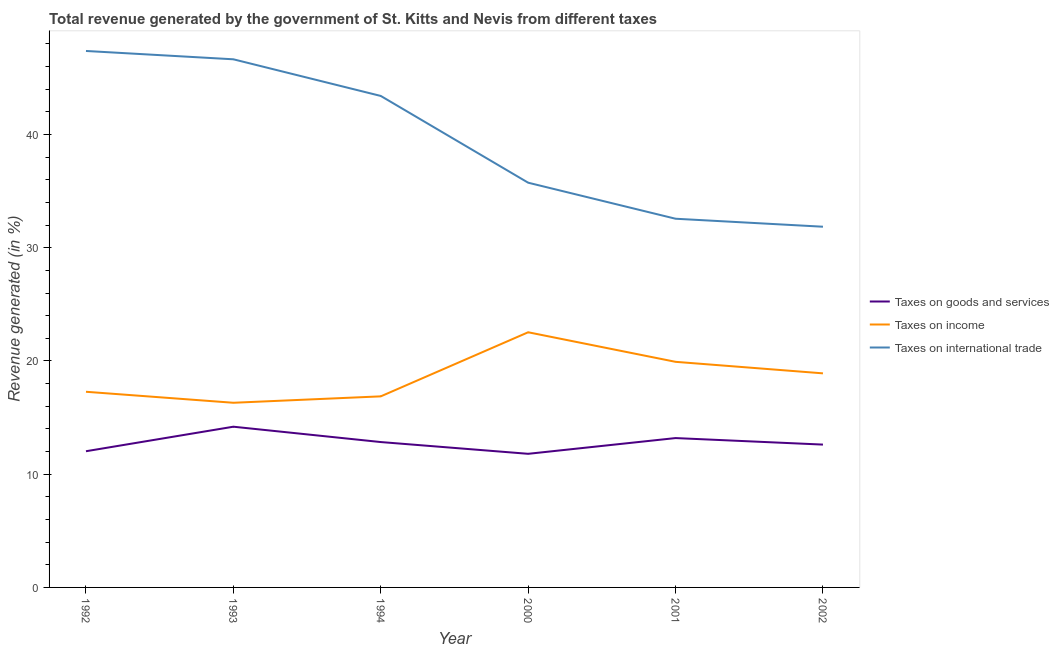Does the line corresponding to percentage of revenue generated by taxes on goods and services intersect with the line corresponding to percentage of revenue generated by tax on international trade?
Keep it short and to the point. No. Is the number of lines equal to the number of legend labels?
Provide a succinct answer. Yes. What is the percentage of revenue generated by tax on international trade in 2000?
Your response must be concise. 35.74. Across all years, what is the maximum percentage of revenue generated by taxes on goods and services?
Your answer should be very brief. 14.19. Across all years, what is the minimum percentage of revenue generated by taxes on goods and services?
Provide a short and direct response. 11.8. In which year was the percentage of revenue generated by taxes on goods and services minimum?
Keep it short and to the point. 2000. What is the total percentage of revenue generated by tax on international trade in the graph?
Provide a short and direct response. 237.59. What is the difference between the percentage of revenue generated by taxes on goods and services in 2001 and that in 2002?
Your answer should be very brief. 0.58. What is the difference between the percentage of revenue generated by taxes on income in 1993 and the percentage of revenue generated by tax on international trade in 2000?
Your response must be concise. -19.44. What is the average percentage of revenue generated by taxes on income per year?
Make the answer very short. 18.64. In the year 1994, what is the difference between the percentage of revenue generated by taxes on income and percentage of revenue generated by tax on international trade?
Offer a very short reply. -26.53. In how many years, is the percentage of revenue generated by tax on international trade greater than 24 %?
Give a very brief answer. 6. What is the ratio of the percentage of revenue generated by tax on international trade in 2000 to that in 2002?
Give a very brief answer. 1.12. Is the percentage of revenue generated by taxes on goods and services in 1992 less than that in 2000?
Provide a short and direct response. No. What is the difference between the highest and the second highest percentage of revenue generated by taxes on income?
Provide a short and direct response. 2.61. What is the difference between the highest and the lowest percentage of revenue generated by taxes on goods and services?
Provide a succinct answer. 2.39. In how many years, is the percentage of revenue generated by taxes on income greater than the average percentage of revenue generated by taxes on income taken over all years?
Your answer should be compact. 3. Is the sum of the percentage of revenue generated by taxes on goods and services in 2000 and 2001 greater than the maximum percentage of revenue generated by tax on international trade across all years?
Your answer should be compact. No. Is it the case that in every year, the sum of the percentage of revenue generated by taxes on goods and services and percentage of revenue generated by taxes on income is greater than the percentage of revenue generated by tax on international trade?
Ensure brevity in your answer.  No. Does the percentage of revenue generated by tax on international trade monotonically increase over the years?
Give a very brief answer. No. How many years are there in the graph?
Keep it short and to the point. 6. What is the difference between two consecutive major ticks on the Y-axis?
Offer a very short reply. 10. Are the values on the major ticks of Y-axis written in scientific E-notation?
Provide a succinct answer. No. Where does the legend appear in the graph?
Keep it short and to the point. Center right. How many legend labels are there?
Your response must be concise. 3. How are the legend labels stacked?
Your answer should be compact. Vertical. What is the title of the graph?
Offer a very short reply. Total revenue generated by the government of St. Kitts and Nevis from different taxes. Does "Taxes" appear as one of the legend labels in the graph?
Ensure brevity in your answer.  No. What is the label or title of the X-axis?
Offer a terse response. Year. What is the label or title of the Y-axis?
Your answer should be compact. Revenue generated (in %). What is the Revenue generated (in %) of Taxes on goods and services in 1992?
Ensure brevity in your answer.  12.03. What is the Revenue generated (in %) in Taxes on income in 1992?
Your response must be concise. 17.28. What is the Revenue generated (in %) of Taxes on international trade in 1992?
Your response must be concise. 47.38. What is the Revenue generated (in %) of Taxes on goods and services in 1993?
Offer a very short reply. 14.19. What is the Revenue generated (in %) in Taxes on income in 1993?
Keep it short and to the point. 16.31. What is the Revenue generated (in %) in Taxes on international trade in 1993?
Your answer should be very brief. 46.64. What is the Revenue generated (in %) in Taxes on goods and services in 1994?
Your answer should be very brief. 12.84. What is the Revenue generated (in %) of Taxes on income in 1994?
Ensure brevity in your answer.  16.87. What is the Revenue generated (in %) in Taxes on international trade in 1994?
Offer a terse response. 43.41. What is the Revenue generated (in %) of Taxes on goods and services in 2000?
Keep it short and to the point. 11.8. What is the Revenue generated (in %) in Taxes on income in 2000?
Provide a short and direct response. 22.54. What is the Revenue generated (in %) in Taxes on international trade in 2000?
Offer a terse response. 35.74. What is the Revenue generated (in %) in Taxes on goods and services in 2001?
Make the answer very short. 13.19. What is the Revenue generated (in %) of Taxes on income in 2001?
Offer a terse response. 19.92. What is the Revenue generated (in %) of Taxes on international trade in 2001?
Your answer should be very brief. 32.56. What is the Revenue generated (in %) in Taxes on goods and services in 2002?
Ensure brevity in your answer.  12.61. What is the Revenue generated (in %) of Taxes on income in 2002?
Your answer should be very brief. 18.91. What is the Revenue generated (in %) in Taxes on international trade in 2002?
Offer a very short reply. 31.86. Across all years, what is the maximum Revenue generated (in %) in Taxes on goods and services?
Provide a short and direct response. 14.19. Across all years, what is the maximum Revenue generated (in %) of Taxes on income?
Your answer should be very brief. 22.54. Across all years, what is the maximum Revenue generated (in %) of Taxes on international trade?
Your answer should be compact. 47.38. Across all years, what is the minimum Revenue generated (in %) in Taxes on goods and services?
Keep it short and to the point. 11.8. Across all years, what is the minimum Revenue generated (in %) of Taxes on income?
Make the answer very short. 16.31. Across all years, what is the minimum Revenue generated (in %) of Taxes on international trade?
Your answer should be compact. 31.86. What is the total Revenue generated (in %) of Taxes on goods and services in the graph?
Your answer should be very brief. 76.67. What is the total Revenue generated (in %) in Taxes on income in the graph?
Your answer should be very brief. 111.83. What is the total Revenue generated (in %) of Taxes on international trade in the graph?
Ensure brevity in your answer.  237.59. What is the difference between the Revenue generated (in %) of Taxes on goods and services in 1992 and that in 1993?
Provide a succinct answer. -2.17. What is the difference between the Revenue generated (in %) in Taxes on income in 1992 and that in 1993?
Give a very brief answer. 0.97. What is the difference between the Revenue generated (in %) of Taxes on international trade in 1992 and that in 1993?
Offer a terse response. 0.74. What is the difference between the Revenue generated (in %) of Taxes on goods and services in 1992 and that in 1994?
Offer a very short reply. -0.81. What is the difference between the Revenue generated (in %) in Taxes on income in 1992 and that in 1994?
Your answer should be very brief. 0.4. What is the difference between the Revenue generated (in %) in Taxes on international trade in 1992 and that in 1994?
Offer a very short reply. 3.97. What is the difference between the Revenue generated (in %) in Taxes on goods and services in 1992 and that in 2000?
Your answer should be compact. 0.23. What is the difference between the Revenue generated (in %) of Taxes on income in 1992 and that in 2000?
Offer a terse response. -5.26. What is the difference between the Revenue generated (in %) of Taxes on international trade in 1992 and that in 2000?
Your response must be concise. 11.63. What is the difference between the Revenue generated (in %) in Taxes on goods and services in 1992 and that in 2001?
Keep it short and to the point. -1.16. What is the difference between the Revenue generated (in %) of Taxes on income in 1992 and that in 2001?
Your answer should be very brief. -2.64. What is the difference between the Revenue generated (in %) in Taxes on international trade in 1992 and that in 2001?
Offer a terse response. 14.82. What is the difference between the Revenue generated (in %) in Taxes on goods and services in 1992 and that in 2002?
Give a very brief answer. -0.59. What is the difference between the Revenue generated (in %) in Taxes on income in 1992 and that in 2002?
Offer a very short reply. -1.63. What is the difference between the Revenue generated (in %) in Taxes on international trade in 1992 and that in 2002?
Your answer should be compact. 15.52. What is the difference between the Revenue generated (in %) in Taxes on goods and services in 1993 and that in 1994?
Give a very brief answer. 1.35. What is the difference between the Revenue generated (in %) in Taxes on income in 1993 and that in 1994?
Your answer should be very brief. -0.57. What is the difference between the Revenue generated (in %) in Taxes on international trade in 1993 and that in 1994?
Offer a terse response. 3.24. What is the difference between the Revenue generated (in %) in Taxes on goods and services in 1993 and that in 2000?
Keep it short and to the point. 2.39. What is the difference between the Revenue generated (in %) in Taxes on income in 1993 and that in 2000?
Make the answer very short. -6.23. What is the difference between the Revenue generated (in %) of Taxes on international trade in 1993 and that in 2000?
Your answer should be very brief. 10.9. What is the difference between the Revenue generated (in %) of Taxes on goods and services in 1993 and that in 2001?
Ensure brevity in your answer.  1. What is the difference between the Revenue generated (in %) of Taxes on income in 1993 and that in 2001?
Give a very brief answer. -3.62. What is the difference between the Revenue generated (in %) of Taxes on international trade in 1993 and that in 2001?
Offer a terse response. 14.08. What is the difference between the Revenue generated (in %) of Taxes on goods and services in 1993 and that in 2002?
Provide a short and direct response. 1.58. What is the difference between the Revenue generated (in %) of Taxes on income in 1993 and that in 2002?
Provide a succinct answer. -2.6. What is the difference between the Revenue generated (in %) of Taxes on international trade in 1993 and that in 2002?
Provide a short and direct response. 14.79. What is the difference between the Revenue generated (in %) in Taxes on goods and services in 1994 and that in 2000?
Your answer should be very brief. 1.04. What is the difference between the Revenue generated (in %) in Taxes on income in 1994 and that in 2000?
Your answer should be very brief. -5.66. What is the difference between the Revenue generated (in %) in Taxes on international trade in 1994 and that in 2000?
Make the answer very short. 7.66. What is the difference between the Revenue generated (in %) of Taxes on goods and services in 1994 and that in 2001?
Give a very brief answer. -0.35. What is the difference between the Revenue generated (in %) in Taxes on income in 1994 and that in 2001?
Your response must be concise. -3.05. What is the difference between the Revenue generated (in %) of Taxes on international trade in 1994 and that in 2001?
Your answer should be very brief. 10.84. What is the difference between the Revenue generated (in %) of Taxes on goods and services in 1994 and that in 2002?
Make the answer very short. 0.22. What is the difference between the Revenue generated (in %) in Taxes on income in 1994 and that in 2002?
Your response must be concise. -2.03. What is the difference between the Revenue generated (in %) in Taxes on international trade in 1994 and that in 2002?
Keep it short and to the point. 11.55. What is the difference between the Revenue generated (in %) of Taxes on goods and services in 2000 and that in 2001?
Offer a terse response. -1.39. What is the difference between the Revenue generated (in %) in Taxes on income in 2000 and that in 2001?
Offer a very short reply. 2.61. What is the difference between the Revenue generated (in %) in Taxes on international trade in 2000 and that in 2001?
Offer a very short reply. 3.18. What is the difference between the Revenue generated (in %) of Taxes on goods and services in 2000 and that in 2002?
Provide a succinct answer. -0.81. What is the difference between the Revenue generated (in %) of Taxes on income in 2000 and that in 2002?
Give a very brief answer. 3.63. What is the difference between the Revenue generated (in %) in Taxes on international trade in 2000 and that in 2002?
Provide a short and direct response. 3.89. What is the difference between the Revenue generated (in %) of Taxes on goods and services in 2001 and that in 2002?
Ensure brevity in your answer.  0.58. What is the difference between the Revenue generated (in %) of Taxes on income in 2001 and that in 2002?
Make the answer very short. 1.02. What is the difference between the Revenue generated (in %) of Taxes on international trade in 2001 and that in 2002?
Keep it short and to the point. 0.71. What is the difference between the Revenue generated (in %) in Taxes on goods and services in 1992 and the Revenue generated (in %) in Taxes on income in 1993?
Keep it short and to the point. -4.28. What is the difference between the Revenue generated (in %) of Taxes on goods and services in 1992 and the Revenue generated (in %) of Taxes on international trade in 1993?
Provide a succinct answer. -34.62. What is the difference between the Revenue generated (in %) of Taxes on income in 1992 and the Revenue generated (in %) of Taxes on international trade in 1993?
Ensure brevity in your answer.  -29.36. What is the difference between the Revenue generated (in %) of Taxes on goods and services in 1992 and the Revenue generated (in %) of Taxes on income in 1994?
Your answer should be compact. -4.85. What is the difference between the Revenue generated (in %) in Taxes on goods and services in 1992 and the Revenue generated (in %) in Taxes on international trade in 1994?
Offer a very short reply. -31.38. What is the difference between the Revenue generated (in %) of Taxes on income in 1992 and the Revenue generated (in %) of Taxes on international trade in 1994?
Your answer should be very brief. -26.13. What is the difference between the Revenue generated (in %) in Taxes on goods and services in 1992 and the Revenue generated (in %) in Taxes on income in 2000?
Your answer should be very brief. -10.51. What is the difference between the Revenue generated (in %) of Taxes on goods and services in 1992 and the Revenue generated (in %) of Taxes on international trade in 2000?
Keep it short and to the point. -23.72. What is the difference between the Revenue generated (in %) in Taxes on income in 1992 and the Revenue generated (in %) in Taxes on international trade in 2000?
Provide a short and direct response. -18.46. What is the difference between the Revenue generated (in %) of Taxes on goods and services in 1992 and the Revenue generated (in %) of Taxes on income in 2001?
Make the answer very short. -7.9. What is the difference between the Revenue generated (in %) in Taxes on goods and services in 1992 and the Revenue generated (in %) in Taxes on international trade in 2001?
Your response must be concise. -20.53. What is the difference between the Revenue generated (in %) in Taxes on income in 1992 and the Revenue generated (in %) in Taxes on international trade in 2001?
Provide a short and direct response. -15.28. What is the difference between the Revenue generated (in %) in Taxes on goods and services in 1992 and the Revenue generated (in %) in Taxes on income in 2002?
Make the answer very short. -6.88. What is the difference between the Revenue generated (in %) of Taxes on goods and services in 1992 and the Revenue generated (in %) of Taxes on international trade in 2002?
Offer a terse response. -19.83. What is the difference between the Revenue generated (in %) in Taxes on income in 1992 and the Revenue generated (in %) in Taxes on international trade in 2002?
Keep it short and to the point. -14.58. What is the difference between the Revenue generated (in %) of Taxes on goods and services in 1993 and the Revenue generated (in %) of Taxes on income in 1994?
Offer a terse response. -2.68. What is the difference between the Revenue generated (in %) in Taxes on goods and services in 1993 and the Revenue generated (in %) in Taxes on international trade in 1994?
Your answer should be very brief. -29.21. What is the difference between the Revenue generated (in %) in Taxes on income in 1993 and the Revenue generated (in %) in Taxes on international trade in 1994?
Ensure brevity in your answer.  -27.1. What is the difference between the Revenue generated (in %) of Taxes on goods and services in 1993 and the Revenue generated (in %) of Taxes on income in 2000?
Ensure brevity in your answer.  -8.34. What is the difference between the Revenue generated (in %) in Taxes on goods and services in 1993 and the Revenue generated (in %) in Taxes on international trade in 2000?
Ensure brevity in your answer.  -21.55. What is the difference between the Revenue generated (in %) of Taxes on income in 1993 and the Revenue generated (in %) of Taxes on international trade in 2000?
Provide a succinct answer. -19.44. What is the difference between the Revenue generated (in %) in Taxes on goods and services in 1993 and the Revenue generated (in %) in Taxes on income in 2001?
Your answer should be very brief. -5.73. What is the difference between the Revenue generated (in %) of Taxes on goods and services in 1993 and the Revenue generated (in %) of Taxes on international trade in 2001?
Give a very brief answer. -18.37. What is the difference between the Revenue generated (in %) of Taxes on income in 1993 and the Revenue generated (in %) of Taxes on international trade in 2001?
Provide a succinct answer. -16.25. What is the difference between the Revenue generated (in %) of Taxes on goods and services in 1993 and the Revenue generated (in %) of Taxes on income in 2002?
Your response must be concise. -4.71. What is the difference between the Revenue generated (in %) of Taxes on goods and services in 1993 and the Revenue generated (in %) of Taxes on international trade in 2002?
Offer a terse response. -17.66. What is the difference between the Revenue generated (in %) in Taxes on income in 1993 and the Revenue generated (in %) in Taxes on international trade in 2002?
Provide a short and direct response. -15.55. What is the difference between the Revenue generated (in %) of Taxes on goods and services in 1994 and the Revenue generated (in %) of Taxes on income in 2000?
Offer a terse response. -9.7. What is the difference between the Revenue generated (in %) in Taxes on goods and services in 1994 and the Revenue generated (in %) in Taxes on international trade in 2000?
Your response must be concise. -22.91. What is the difference between the Revenue generated (in %) of Taxes on income in 1994 and the Revenue generated (in %) of Taxes on international trade in 2000?
Your response must be concise. -18.87. What is the difference between the Revenue generated (in %) of Taxes on goods and services in 1994 and the Revenue generated (in %) of Taxes on income in 2001?
Make the answer very short. -7.09. What is the difference between the Revenue generated (in %) of Taxes on goods and services in 1994 and the Revenue generated (in %) of Taxes on international trade in 2001?
Your answer should be compact. -19.72. What is the difference between the Revenue generated (in %) in Taxes on income in 1994 and the Revenue generated (in %) in Taxes on international trade in 2001?
Offer a terse response. -15.69. What is the difference between the Revenue generated (in %) in Taxes on goods and services in 1994 and the Revenue generated (in %) in Taxes on income in 2002?
Offer a very short reply. -6.07. What is the difference between the Revenue generated (in %) of Taxes on goods and services in 1994 and the Revenue generated (in %) of Taxes on international trade in 2002?
Your answer should be very brief. -19.02. What is the difference between the Revenue generated (in %) of Taxes on income in 1994 and the Revenue generated (in %) of Taxes on international trade in 2002?
Offer a very short reply. -14.98. What is the difference between the Revenue generated (in %) in Taxes on goods and services in 2000 and the Revenue generated (in %) in Taxes on income in 2001?
Ensure brevity in your answer.  -8.12. What is the difference between the Revenue generated (in %) in Taxes on goods and services in 2000 and the Revenue generated (in %) in Taxes on international trade in 2001?
Your answer should be very brief. -20.76. What is the difference between the Revenue generated (in %) in Taxes on income in 2000 and the Revenue generated (in %) in Taxes on international trade in 2001?
Keep it short and to the point. -10.03. What is the difference between the Revenue generated (in %) of Taxes on goods and services in 2000 and the Revenue generated (in %) of Taxes on income in 2002?
Keep it short and to the point. -7.11. What is the difference between the Revenue generated (in %) in Taxes on goods and services in 2000 and the Revenue generated (in %) in Taxes on international trade in 2002?
Provide a short and direct response. -20.06. What is the difference between the Revenue generated (in %) of Taxes on income in 2000 and the Revenue generated (in %) of Taxes on international trade in 2002?
Provide a short and direct response. -9.32. What is the difference between the Revenue generated (in %) in Taxes on goods and services in 2001 and the Revenue generated (in %) in Taxes on income in 2002?
Your answer should be very brief. -5.72. What is the difference between the Revenue generated (in %) of Taxes on goods and services in 2001 and the Revenue generated (in %) of Taxes on international trade in 2002?
Your answer should be compact. -18.67. What is the difference between the Revenue generated (in %) in Taxes on income in 2001 and the Revenue generated (in %) in Taxes on international trade in 2002?
Give a very brief answer. -11.93. What is the average Revenue generated (in %) of Taxes on goods and services per year?
Provide a succinct answer. 12.78. What is the average Revenue generated (in %) of Taxes on income per year?
Your answer should be compact. 18.64. What is the average Revenue generated (in %) of Taxes on international trade per year?
Give a very brief answer. 39.6. In the year 1992, what is the difference between the Revenue generated (in %) in Taxes on goods and services and Revenue generated (in %) in Taxes on income?
Give a very brief answer. -5.25. In the year 1992, what is the difference between the Revenue generated (in %) in Taxes on goods and services and Revenue generated (in %) in Taxes on international trade?
Provide a succinct answer. -35.35. In the year 1992, what is the difference between the Revenue generated (in %) of Taxes on income and Revenue generated (in %) of Taxes on international trade?
Keep it short and to the point. -30.1. In the year 1993, what is the difference between the Revenue generated (in %) in Taxes on goods and services and Revenue generated (in %) in Taxes on income?
Your response must be concise. -2.12. In the year 1993, what is the difference between the Revenue generated (in %) in Taxes on goods and services and Revenue generated (in %) in Taxes on international trade?
Offer a very short reply. -32.45. In the year 1993, what is the difference between the Revenue generated (in %) of Taxes on income and Revenue generated (in %) of Taxes on international trade?
Offer a terse response. -30.33. In the year 1994, what is the difference between the Revenue generated (in %) in Taxes on goods and services and Revenue generated (in %) in Taxes on income?
Give a very brief answer. -4.04. In the year 1994, what is the difference between the Revenue generated (in %) of Taxes on goods and services and Revenue generated (in %) of Taxes on international trade?
Your answer should be very brief. -30.57. In the year 1994, what is the difference between the Revenue generated (in %) of Taxes on income and Revenue generated (in %) of Taxes on international trade?
Ensure brevity in your answer.  -26.53. In the year 2000, what is the difference between the Revenue generated (in %) of Taxes on goods and services and Revenue generated (in %) of Taxes on income?
Make the answer very short. -10.73. In the year 2000, what is the difference between the Revenue generated (in %) in Taxes on goods and services and Revenue generated (in %) in Taxes on international trade?
Offer a very short reply. -23.94. In the year 2000, what is the difference between the Revenue generated (in %) of Taxes on income and Revenue generated (in %) of Taxes on international trade?
Provide a short and direct response. -13.21. In the year 2001, what is the difference between the Revenue generated (in %) of Taxes on goods and services and Revenue generated (in %) of Taxes on income?
Offer a terse response. -6.73. In the year 2001, what is the difference between the Revenue generated (in %) in Taxes on goods and services and Revenue generated (in %) in Taxes on international trade?
Make the answer very short. -19.37. In the year 2001, what is the difference between the Revenue generated (in %) of Taxes on income and Revenue generated (in %) of Taxes on international trade?
Give a very brief answer. -12.64. In the year 2002, what is the difference between the Revenue generated (in %) in Taxes on goods and services and Revenue generated (in %) in Taxes on income?
Give a very brief answer. -6.29. In the year 2002, what is the difference between the Revenue generated (in %) in Taxes on goods and services and Revenue generated (in %) in Taxes on international trade?
Your answer should be very brief. -19.24. In the year 2002, what is the difference between the Revenue generated (in %) of Taxes on income and Revenue generated (in %) of Taxes on international trade?
Your answer should be very brief. -12.95. What is the ratio of the Revenue generated (in %) in Taxes on goods and services in 1992 to that in 1993?
Give a very brief answer. 0.85. What is the ratio of the Revenue generated (in %) of Taxes on income in 1992 to that in 1993?
Make the answer very short. 1.06. What is the ratio of the Revenue generated (in %) of Taxes on international trade in 1992 to that in 1993?
Make the answer very short. 1.02. What is the ratio of the Revenue generated (in %) of Taxes on goods and services in 1992 to that in 1994?
Make the answer very short. 0.94. What is the ratio of the Revenue generated (in %) of Taxes on international trade in 1992 to that in 1994?
Your response must be concise. 1.09. What is the ratio of the Revenue generated (in %) of Taxes on goods and services in 1992 to that in 2000?
Your response must be concise. 1.02. What is the ratio of the Revenue generated (in %) in Taxes on income in 1992 to that in 2000?
Ensure brevity in your answer.  0.77. What is the ratio of the Revenue generated (in %) of Taxes on international trade in 1992 to that in 2000?
Offer a terse response. 1.33. What is the ratio of the Revenue generated (in %) in Taxes on goods and services in 1992 to that in 2001?
Offer a terse response. 0.91. What is the ratio of the Revenue generated (in %) in Taxes on income in 1992 to that in 2001?
Keep it short and to the point. 0.87. What is the ratio of the Revenue generated (in %) of Taxes on international trade in 1992 to that in 2001?
Make the answer very short. 1.46. What is the ratio of the Revenue generated (in %) of Taxes on goods and services in 1992 to that in 2002?
Provide a succinct answer. 0.95. What is the ratio of the Revenue generated (in %) of Taxes on income in 1992 to that in 2002?
Offer a very short reply. 0.91. What is the ratio of the Revenue generated (in %) in Taxes on international trade in 1992 to that in 2002?
Offer a terse response. 1.49. What is the ratio of the Revenue generated (in %) of Taxes on goods and services in 1993 to that in 1994?
Your answer should be very brief. 1.11. What is the ratio of the Revenue generated (in %) of Taxes on income in 1993 to that in 1994?
Make the answer very short. 0.97. What is the ratio of the Revenue generated (in %) in Taxes on international trade in 1993 to that in 1994?
Provide a short and direct response. 1.07. What is the ratio of the Revenue generated (in %) in Taxes on goods and services in 1993 to that in 2000?
Your answer should be very brief. 1.2. What is the ratio of the Revenue generated (in %) of Taxes on income in 1993 to that in 2000?
Offer a very short reply. 0.72. What is the ratio of the Revenue generated (in %) of Taxes on international trade in 1993 to that in 2000?
Ensure brevity in your answer.  1.3. What is the ratio of the Revenue generated (in %) of Taxes on goods and services in 1993 to that in 2001?
Ensure brevity in your answer.  1.08. What is the ratio of the Revenue generated (in %) of Taxes on income in 1993 to that in 2001?
Ensure brevity in your answer.  0.82. What is the ratio of the Revenue generated (in %) of Taxes on international trade in 1993 to that in 2001?
Your answer should be compact. 1.43. What is the ratio of the Revenue generated (in %) of Taxes on goods and services in 1993 to that in 2002?
Ensure brevity in your answer.  1.13. What is the ratio of the Revenue generated (in %) of Taxes on income in 1993 to that in 2002?
Your answer should be very brief. 0.86. What is the ratio of the Revenue generated (in %) of Taxes on international trade in 1993 to that in 2002?
Offer a terse response. 1.46. What is the ratio of the Revenue generated (in %) in Taxes on goods and services in 1994 to that in 2000?
Your response must be concise. 1.09. What is the ratio of the Revenue generated (in %) in Taxes on income in 1994 to that in 2000?
Give a very brief answer. 0.75. What is the ratio of the Revenue generated (in %) in Taxes on international trade in 1994 to that in 2000?
Your response must be concise. 1.21. What is the ratio of the Revenue generated (in %) in Taxes on goods and services in 1994 to that in 2001?
Offer a terse response. 0.97. What is the ratio of the Revenue generated (in %) in Taxes on income in 1994 to that in 2001?
Your response must be concise. 0.85. What is the ratio of the Revenue generated (in %) of Taxes on international trade in 1994 to that in 2001?
Your answer should be compact. 1.33. What is the ratio of the Revenue generated (in %) in Taxes on goods and services in 1994 to that in 2002?
Your answer should be compact. 1.02. What is the ratio of the Revenue generated (in %) of Taxes on income in 1994 to that in 2002?
Your answer should be compact. 0.89. What is the ratio of the Revenue generated (in %) of Taxes on international trade in 1994 to that in 2002?
Your response must be concise. 1.36. What is the ratio of the Revenue generated (in %) of Taxes on goods and services in 2000 to that in 2001?
Ensure brevity in your answer.  0.89. What is the ratio of the Revenue generated (in %) of Taxes on income in 2000 to that in 2001?
Your answer should be very brief. 1.13. What is the ratio of the Revenue generated (in %) in Taxes on international trade in 2000 to that in 2001?
Your answer should be compact. 1.1. What is the ratio of the Revenue generated (in %) in Taxes on goods and services in 2000 to that in 2002?
Keep it short and to the point. 0.94. What is the ratio of the Revenue generated (in %) in Taxes on income in 2000 to that in 2002?
Keep it short and to the point. 1.19. What is the ratio of the Revenue generated (in %) in Taxes on international trade in 2000 to that in 2002?
Offer a very short reply. 1.12. What is the ratio of the Revenue generated (in %) of Taxes on goods and services in 2001 to that in 2002?
Ensure brevity in your answer.  1.05. What is the ratio of the Revenue generated (in %) in Taxes on income in 2001 to that in 2002?
Offer a terse response. 1.05. What is the ratio of the Revenue generated (in %) of Taxes on international trade in 2001 to that in 2002?
Your answer should be very brief. 1.02. What is the difference between the highest and the second highest Revenue generated (in %) in Taxes on income?
Offer a terse response. 2.61. What is the difference between the highest and the second highest Revenue generated (in %) of Taxes on international trade?
Ensure brevity in your answer.  0.74. What is the difference between the highest and the lowest Revenue generated (in %) of Taxes on goods and services?
Provide a short and direct response. 2.39. What is the difference between the highest and the lowest Revenue generated (in %) in Taxes on income?
Give a very brief answer. 6.23. What is the difference between the highest and the lowest Revenue generated (in %) of Taxes on international trade?
Offer a very short reply. 15.52. 